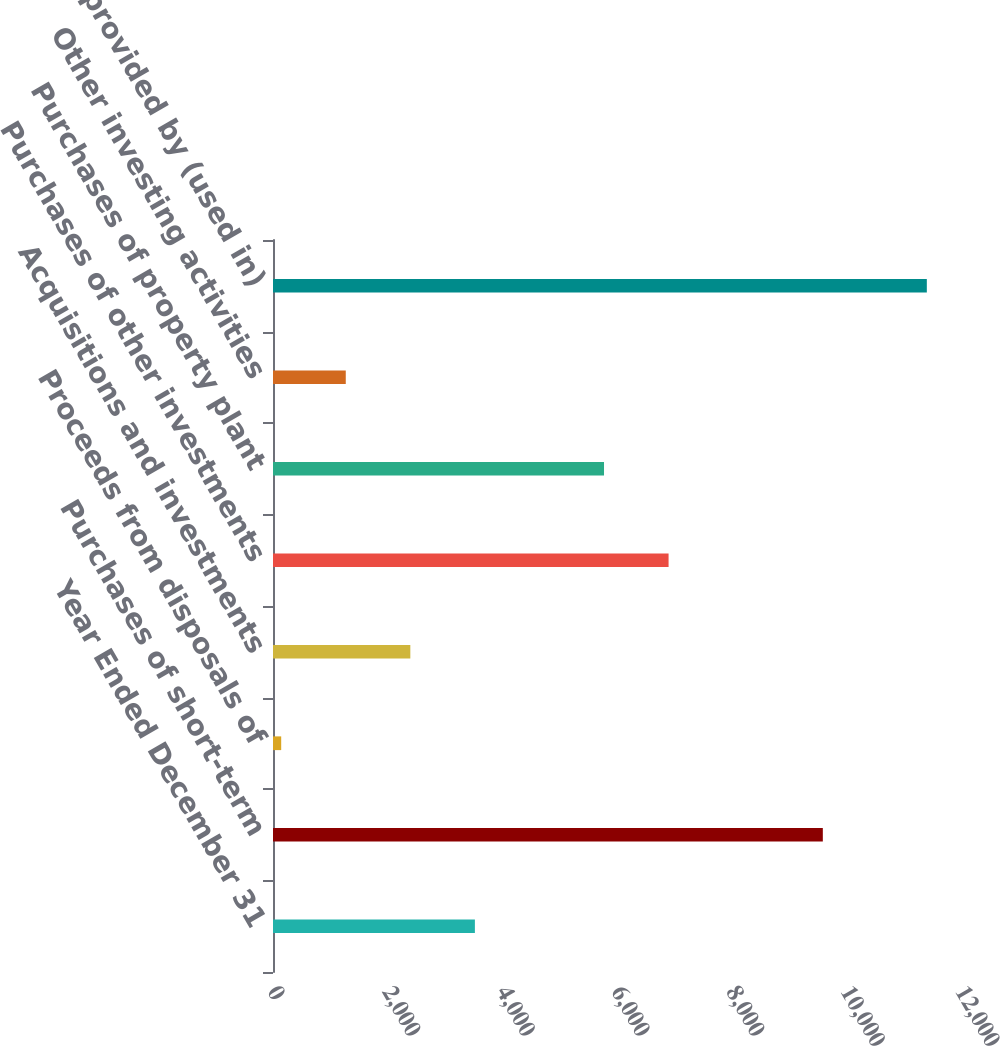<chart> <loc_0><loc_0><loc_500><loc_500><bar_chart><fcel>Year Ended December 31<fcel>Purchases of short-term<fcel>Proceeds from disposals of<fcel>Acquisitions and investments<fcel>Purchases of other investments<fcel>Purchases of property plant<fcel>Other investing activities<fcel>Net cash provided by (used in)<nl><fcel>3521.3<fcel>9590<fcel>143<fcel>2395.2<fcel>6899.6<fcel>5773.5<fcel>1269.1<fcel>11404<nl></chart> 